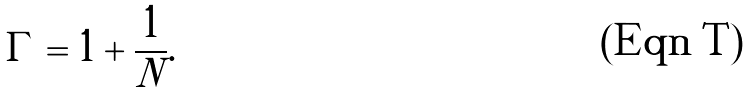<formula> <loc_0><loc_0><loc_500><loc_500>\Gamma = 1 + \frac { 1 } { N } .</formula> 